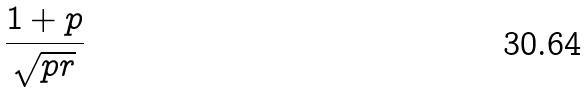Convert formula to latex. <formula><loc_0><loc_0><loc_500><loc_500>\frac { 1 + p } { \sqrt { p r } }</formula> 